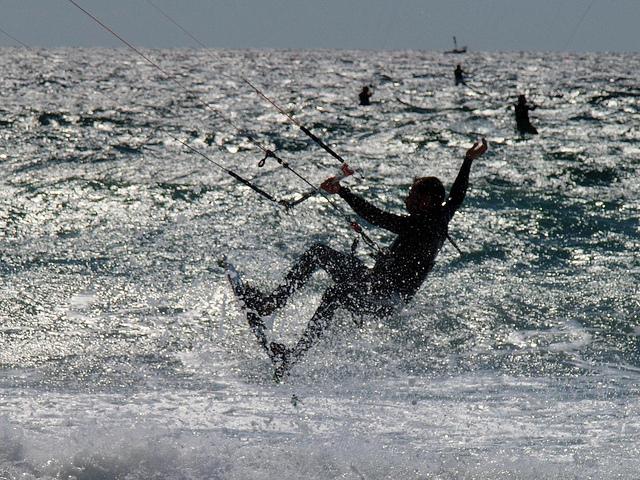Is there a boat in the picture?
Be succinct. Yes. What is the person doing?
Answer briefly. Kitesurfing. How many people are in the water?
Write a very short answer. 4. 